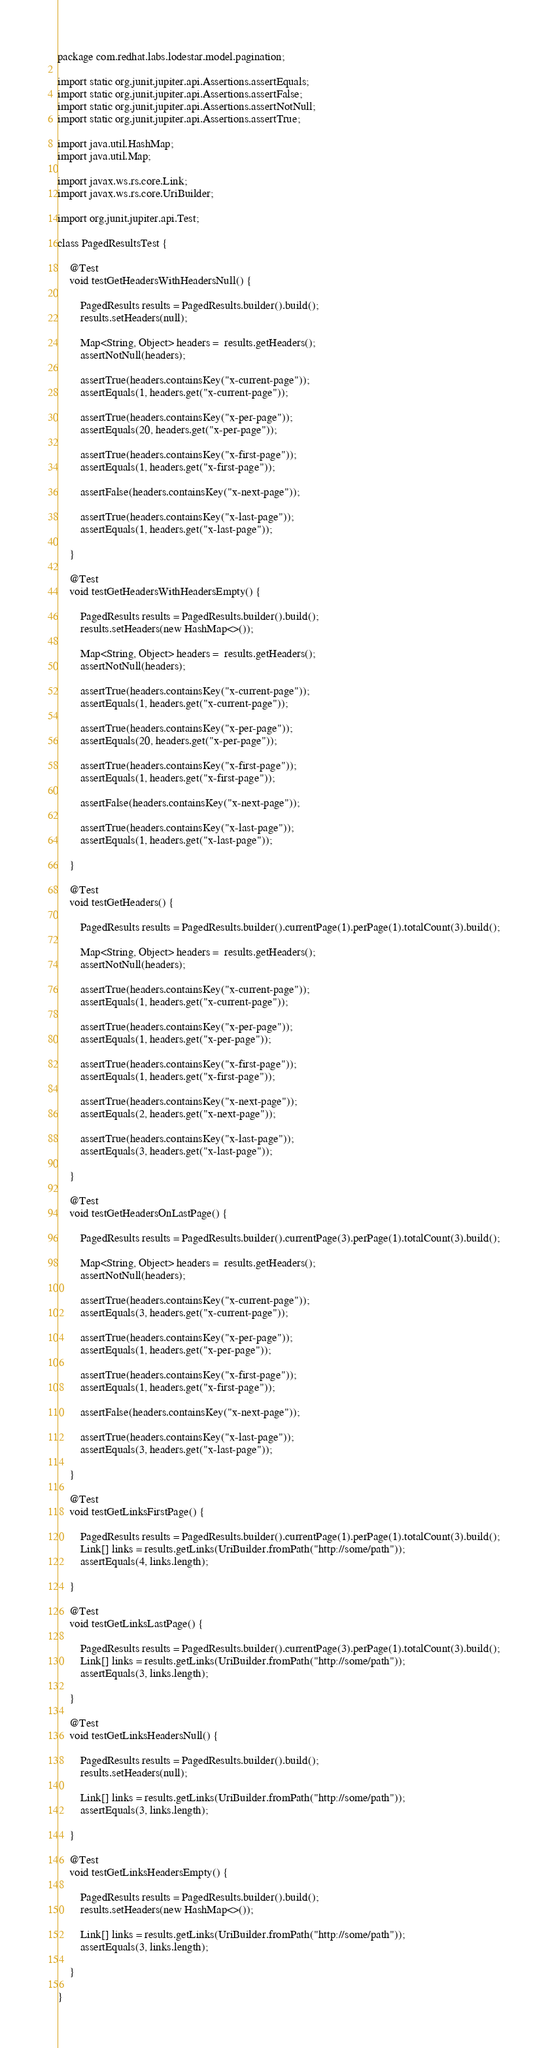<code> <loc_0><loc_0><loc_500><loc_500><_Java_>package com.redhat.labs.lodestar.model.pagination;

import static org.junit.jupiter.api.Assertions.assertEquals;
import static org.junit.jupiter.api.Assertions.assertFalse;
import static org.junit.jupiter.api.Assertions.assertNotNull;
import static org.junit.jupiter.api.Assertions.assertTrue;

import java.util.HashMap;
import java.util.Map;

import javax.ws.rs.core.Link;
import javax.ws.rs.core.UriBuilder;

import org.junit.jupiter.api.Test;

class PagedResultsTest {

    @Test
    void testGetHeadersWithHeadersNull() {

        PagedResults results = PagedResults.builder().build();
        results.setHeaders(null);

        Map<String, Object> headers =  results.getHeaders();
        assertNotNull(headers);

        assertTrue(headers.containsKey("x-current-page"));
        assertEquals(1, headers.get("x-current-page"));

        assertTrue(headers.containsKey("x-per-page"));
        assertEquals(20, headers.get("x-per-page"));

        assertTrue(headers.containsKey("x-first-page"));
        assertEquals(1, headers.get("x-first-page"));

        assertFalse(headers.containsKey("x-next-page"));

        assertTrue(headers.containsKey("x-last-page"));
        assertEquals(1, headers.get("x-last-page"));

    }

    @Test
    void testGetHeadersWithHeadersEmpty() {

        PagedResults results = PagedResults.builder().build();
        results.setHeaders(new HashMap<>());

        Map<String, Object> headers =  results.getHeaders();
        assertNotNull(headers);

        assertTrue(headers.containsKey("x-current-page"));
        assertEquals(1, headers.get("x-current-page"));

        assertTrue(headers.containsKey("x-per-page"));
        assertEquals(20, headers.get("x-per-page"));

        assertTrue(headers.containsKey("x-first-page"));
        assertEquals(1, headers.get("x-first-page"));

        assertFalse(headers.containsKey("x-next-page"));

        assertTrue(headers.containsKey("x-last-page"));
        assertEquals(1, headers.get("x-last-page"));

    }

    @Test
    void testGetHeaders() {

        PagedResults results = PagedResults.builder().currentPage(1).perPage(1).totalCount(3).build();

        Map<String, Object> headers =  results.getHeaders();
        assertNotNull(headers);

        assertTrue(headers.containsKey("x-current-page"));
        assertEquals(1, headers.get("x-current-page"));

        assertTrue(headers.containsKey("x-per-page"));
        assertEquals(1, headers.get("x-per-page"));

        assertTrue(headers.containsKey("x-first-page"));
        assertEquals(1, headers.get("x-first-page"));

        assertTrue(headers.containsKey("x-next-page"));
        assertEquals(2, headers.get("x-next-page"));

        assertTrue(headers.containsKey("x-last-page"));
        assertEquals(3, headers.get("x-last-page"));

    }

    @Test
    void testGetHeadersOnLastPage() {

        PagedResults results = PagedResults.builder().currentPage(3).perPage(1).totalCount(3).build();

        Map<String, Object> headers =  results.getHeaders();
        assertNotNull(headers);

        assertTrue(headers.containsKey("x-current-page"));
        assertEquals(3, headers.get("x-current-page"));

        assertTrue(headers.containsKey("x-per-page"));
        assertEquals(1, headers.get("x-per-page"));

        assertTrue(headers.containsKey("x-first-page"));
        assertEquals(1, headers.get("x-first-page"));

        assertFalse(headers.containsKey("x-next-page"));

        assertTrue(headers.containsKey("x-last-page"));
        assertEquals(3, headers.get("x-last-page"));

    }
    
    @Test
    void testGetLinksFirstPage() {

        PagedResults results = PagedResults.builder().currentPage(1).perPage(1).totalCount(3).build();
        Link[] links = results.getLinks(UriBuilder.fromPath("http://some/path"));
        assertEquals(4, links.length);

    }

    @Test
    void testGetLinksLastPage() {

        PagedResults results = PagedResults.builder().currentPage(3).perPage(1).totalCount(3).build();
        Link[] links = results.getLinks(UriBuilder.fromPath("http://some/path"));
        assertEquals(3, links.length);

    }

    @Test
    void testGetLinksHeadersNull() {

        PagedResults results = PagedResults.builder().build();
        results.setHeaders(null);

        Link[] links = results.getLinks(UriBuilder.fromPath("http://some/path"));
        assertEquals(3, links.length);

    }

    @Test
    void testGetLinksHeadersEmpty() {

        PagedResults results = PagedResults.builder().build();
        results.setHeaders(new HashMap<>());

        Link[] links = results.getLinks(UriBuilder.fromPath("http://some/path"));
        assertEquals(3, links.length);

    }

}
</code> 